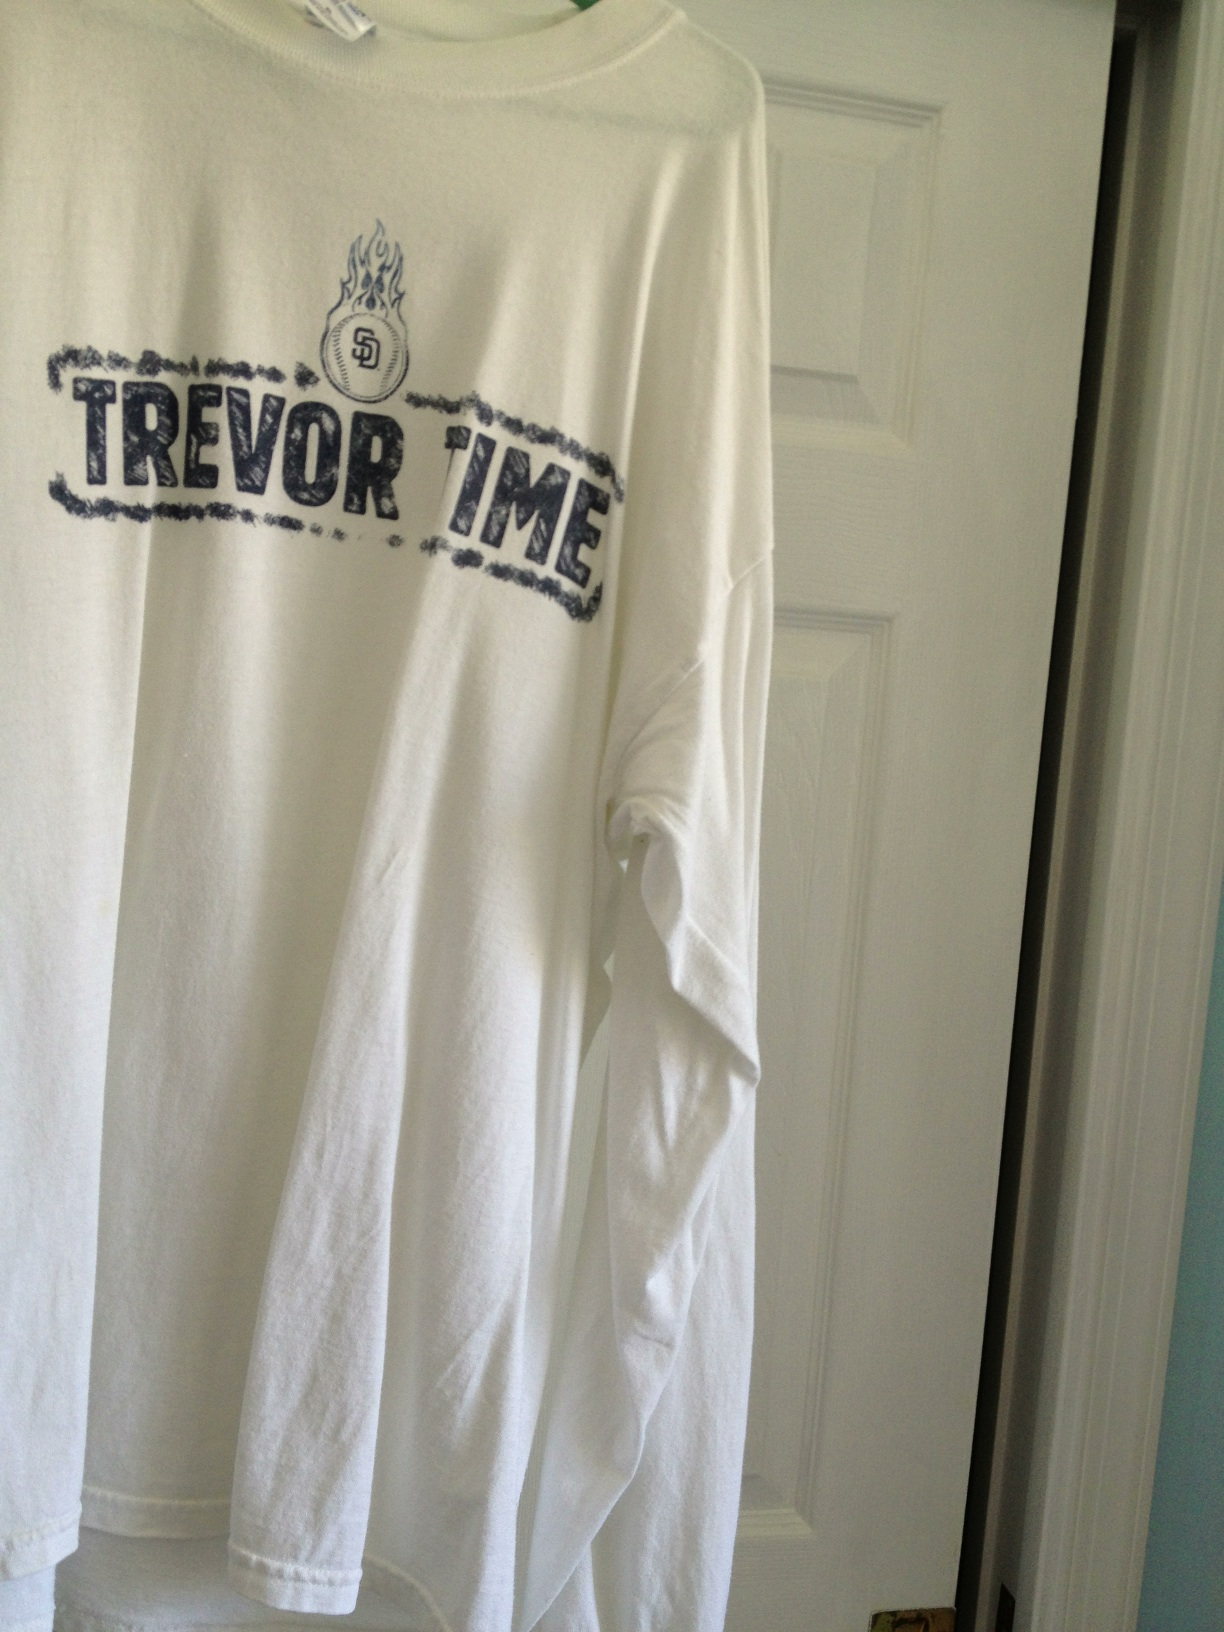What other details can you observe about this shirt? The shirt has a vintage or worn look due to the distressed font of the 'TREVOЯ TIME' text. The long sleeves and the material appear to be comfortable and suitable for cooler weather. The minimal design and single-color printing make it versatile for casual wear. 